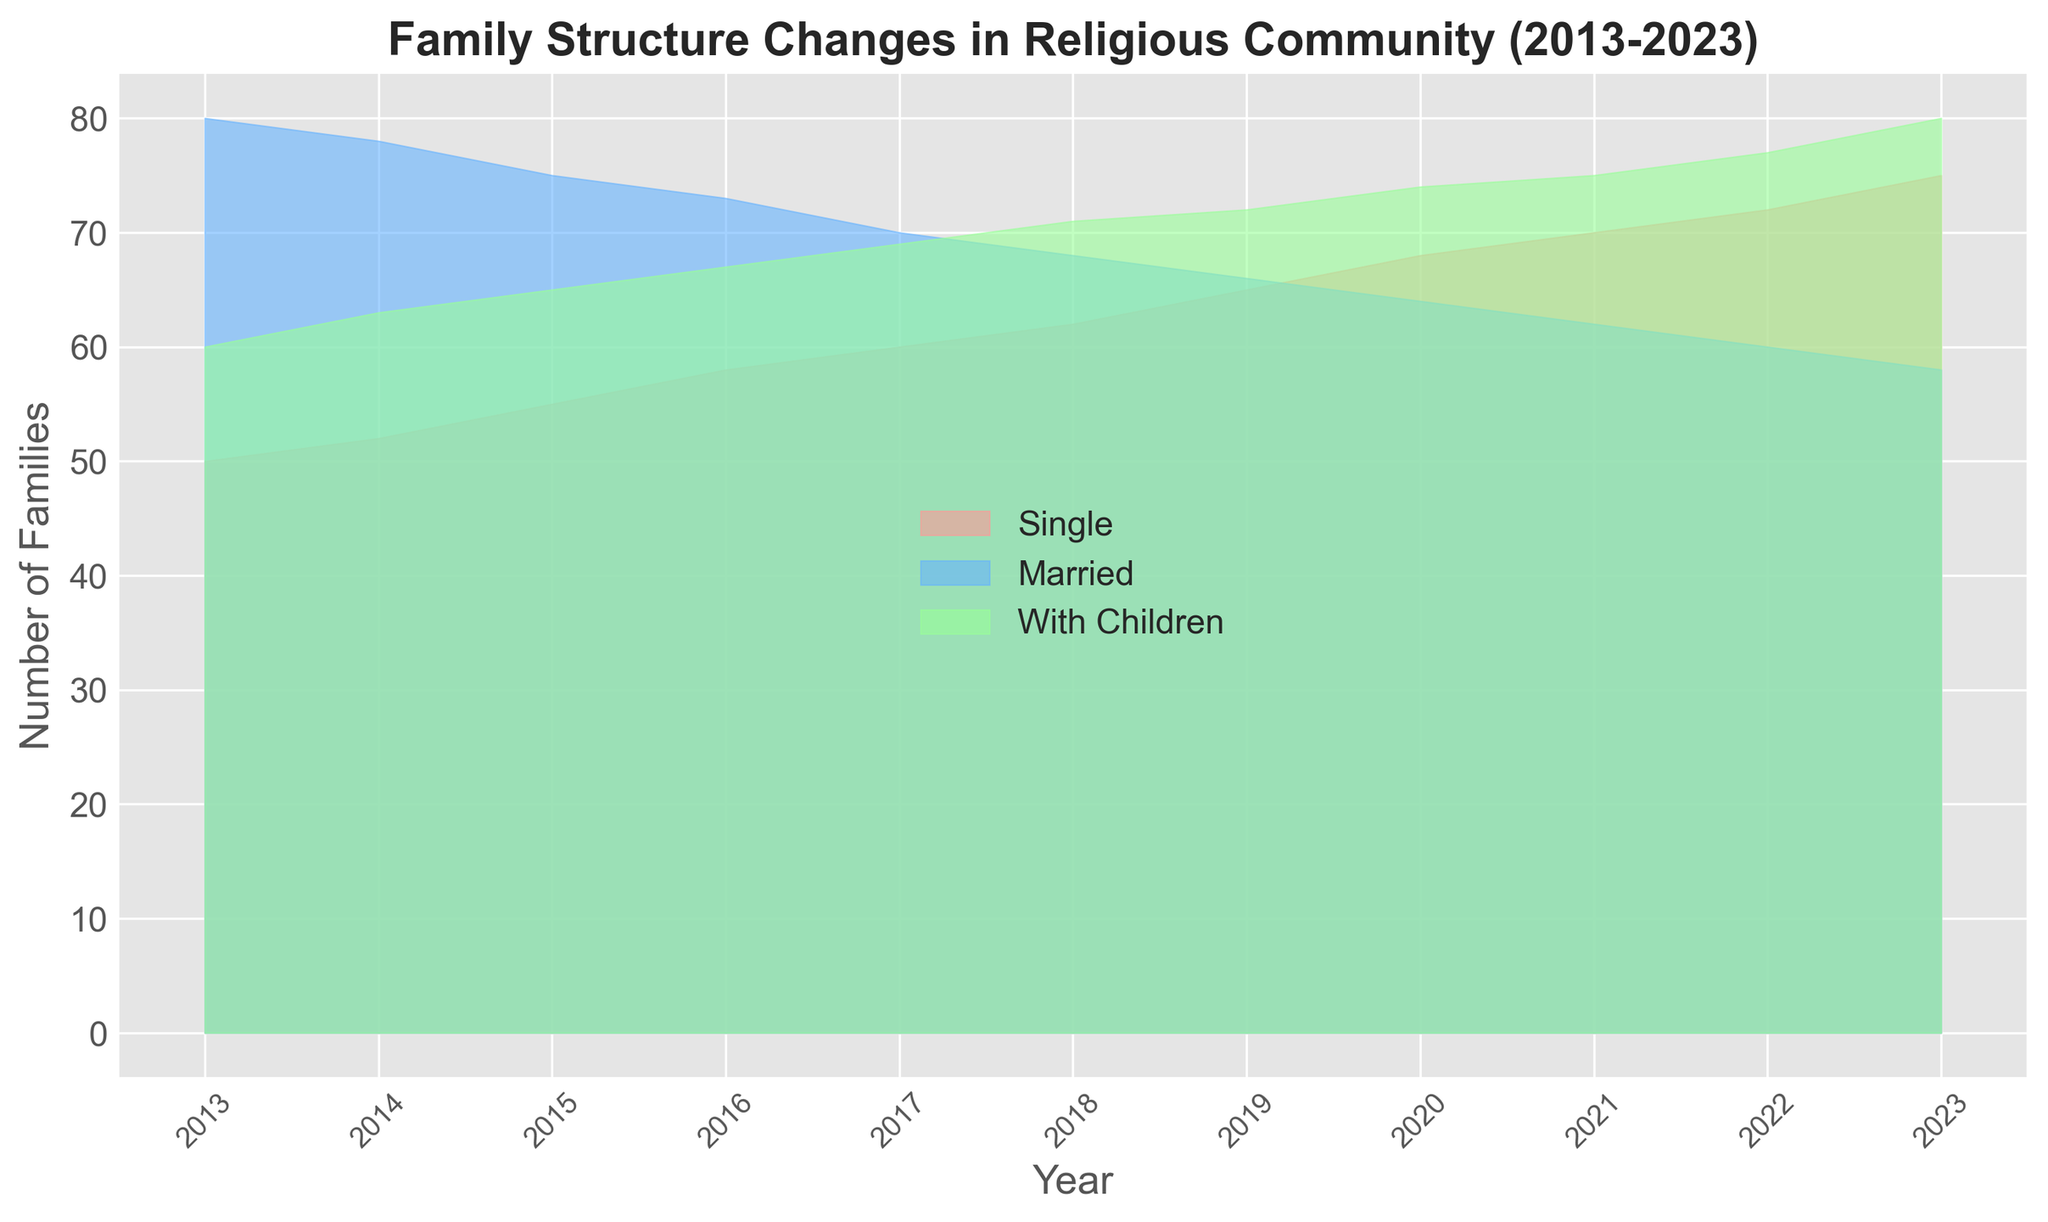What trend can be observed in the "Single" category from 2013 to 2023? Observe the area chart's data for the "Single" category. Over the years, the section representing "Single" increases continuously, indicating a rising trend.
Answer: Increasing Which year had the highest number of families with children? Look at the "With Children" section of the area chart. The largest value is at 2023, where the area reaches its peak.
Answer: 2023 How do the numbers of "Married" families compare between 2013 and 2023? In 2013, the area representing "Married" families is higher than in 2023. This indicates a decrease over the years.
Answer: Decrease What is the difference in the number of "Single" and "Married" families in 2023? In 2023, the number of "Single" families is 75 and the number of "Married" families is 58. The difference is 75 - 58.
Answer: 17 Between which years did the "With Children" category see the most significant increase? Observe and compare the heights of the "With Children" section between consecutive years. The largest increase is between 2016 and 2017, with a visible rise in the area.
Answer: 2016 and 2017 In which year did the number of "Single" families surpass the number of "Married" families? Observe where the "Single" section starts becoming larger than the "Married" section. This occurs around 2019.
Answer: 2019 What is the total number of families in 2015 when combining all three categories? Add the values for "Single", "Married", and "With Children" for 2015: 55 (Single) + 75 (Married) + 65 (With Children). The total is 195.
Answer: 195 How did the number of "With Children" families change between 2018 and 2020? Compare the "With Children" values in 2018 (71) and 2020 (74). The difference is 74 - 71.
Answer: Increased by 3 